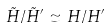<formula> <loc_0><loc_0><loc_500><loc_500>\tilde { H } / \tilde { H } ^ { \prime } \simeq H / H ^ { \prime }</formula> 